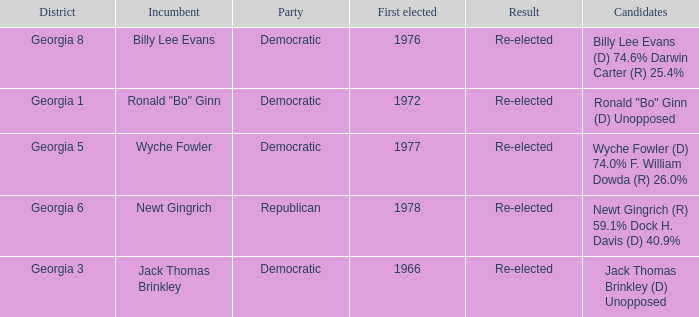Could you help me parse every detail presented in this table? {'header': ['District', 'Incumbent', 'Party', 'First elected', 'Result', 'Candidates'], 'rows': [['Georgia 8', 'Billy Lee Evans', 'Democratic', '1976', 'Re-elected', 'Billy Lee Evans (D) 74.6% Darwin Carter (R) 25.4%'], ['Georgia 1', 'Ronald "Bo" Ginn', 'Democratic', '1972', 'Re-elected', 'Ronald "Bo" Ginn (D) Unopposed'], ['Georgia 5', 'Wyche Fowler', 'Democratic', '1977', 'Re-elected', 'Wyche Fowler (D) 74.0% F. William Dowda (R) 26.0%'], ['Georgia 6', 'Newt Gingrich', 'Republican', '1978', 'Re-elected', 'Newt Gingrich (R) 59.1% Dock H. Davis (D) 40.9%'], ['Georgia 3', 'Jack Thomas Brinkley', 'Democratic', '1966', 'Re-elected', 'Jack Thomas Brinkley (D) Unopposed']]} What is the earliest first elected for district georgia 1? 1972.0. 